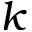<formula> <loc_0><loc_0><loc_500><loc_500>k</formula> 